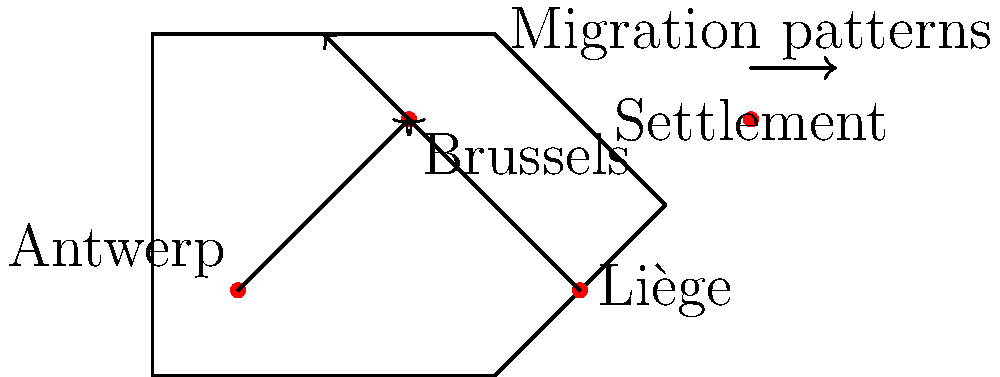Based on the illustrated map of Belgian migration patterns, which city appears to be the primary destination for internal migration during the 19th century industrialization period, and how might this have affected traditional woodworking trades in that area? To answer this question, let's analyze the map and consider historical context:

1. Observe the migration arrows: Two arrows point towards Brussels, while one arrow points away from it towards the north.

2. Identify Brussels as the central point: Brussels is located in the middle of the map and receives incoming migration from both Antwerp and Liège.

3. Consider historical context: The 19th century was a period of industrialization in Belgium, with urban centers growing rapidly.

4. Analyze the impact on woodworking:
   a) Increased urbanization would have created demand for furniture and wooden structures.
   b) However, industrialization might have led to more factory-produced goods, potentially threatening traditional crafts.
   c) The influx of people to Brussels would have increased competition among craftsmen.

5. Consider the outgoing arrow from Brussels:
   This could represent later migration to suburbs or smaller towns, possibly due to overcrowding or seeking better living conditions.

6. Impact on woodworking trades in Brussels:
   a) Initial boost in demand due to population growth.
   b) Potential shift from traditional methods to more industrial production.
   c) Possible specialization in high-end, custom pieces to compete with mass-produced items.
   d) Later migration out of the city might have spread woodworking skills to surrounding areas.
Answer: Brussels; likely increased demand but also competition, potentially forcing adaptation or specialization in traditional woodworking. 